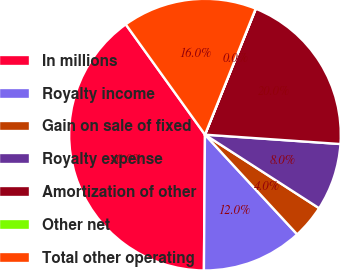<chart> <loc_0><loc_0><loc_500><loc_500><pie_chart><fcel>In millions<fcel>Royalty income<fcel>Gain on sale of fixed<fcel>Royalty expense<fcel>Amortization of other<fcel>Other net<fcel>Total other operating<nl><fcel>39.96%<fcel>12.0%<fcel>4.01%<fcel>8.01%<fcel>19.99%<fcel>0.02%<fcel>16.0%<nl></chart> 